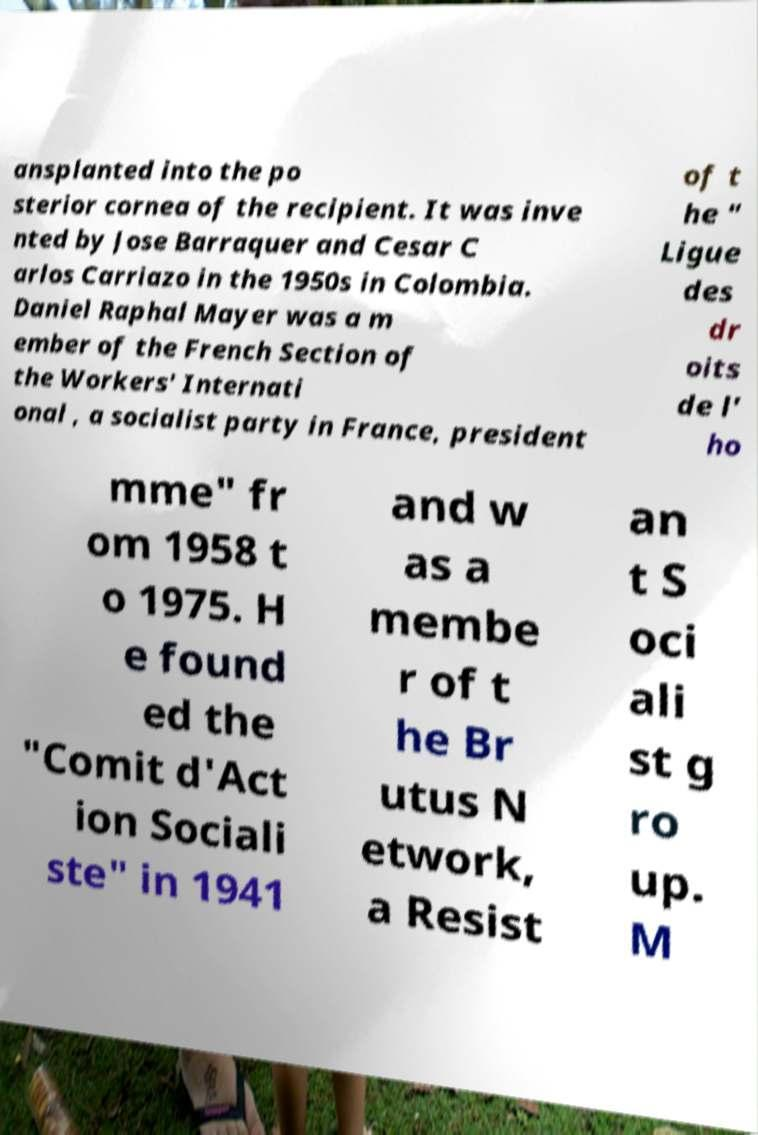Could you assist in decoding the text presented in this image and type it out clearly? ansplanted into the po sterior cornea of the recipient. It was inve nted by Jose Barraquer and Cesar C arlos Carriazo in the 1950s in Colombia. Daniel Raphal Mayer was a m ember of the French Section of the Workers' Internati onal , a socialist party in France, president of t he " Ligue des dr oits de l' ho mme" fr om 1958 t o 1975. H e found ed the "Comit d'Act ion Sociali ste" in 1941 and w as a membe r of t he Br utus N etwork, a Resist an t S oci ali st g ro up. M 